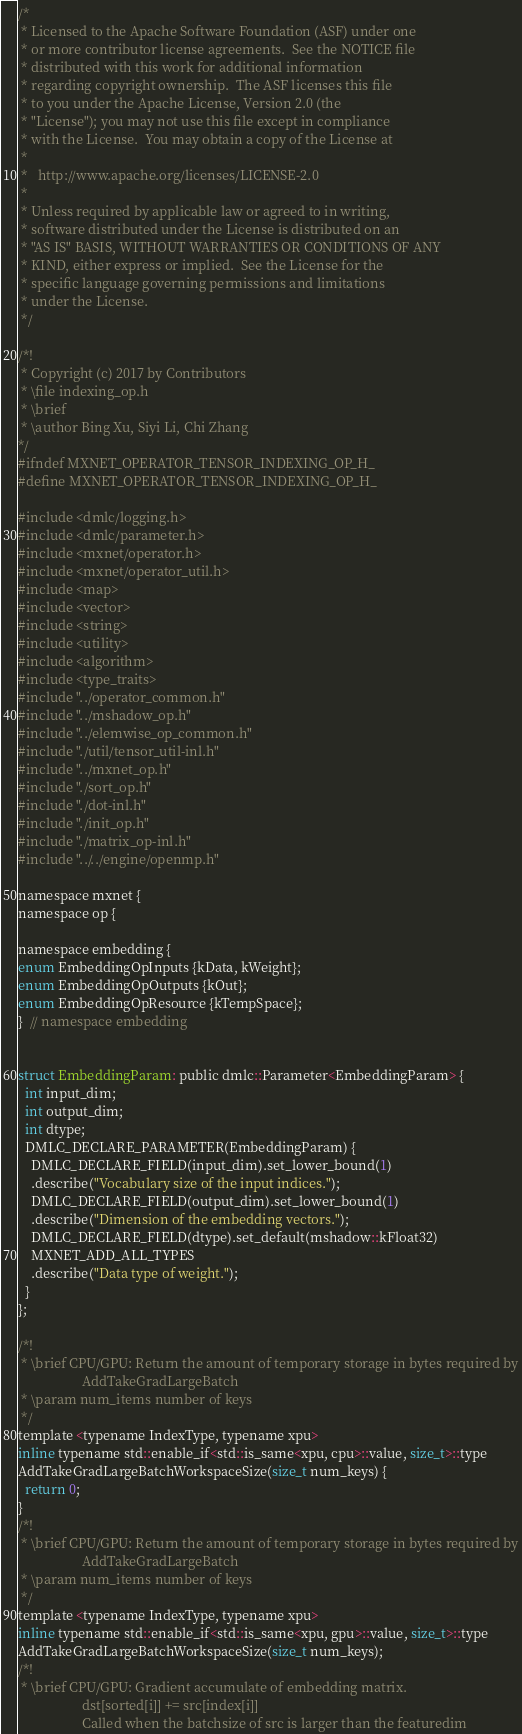Convert code to text. <code><loc_0><loc_0><loc_500><loc_500><_C_>/*
 * Licensed to the Apache Software Foundation (ASF) under one
 * or more contributor license agreements.  See the NOTICE file
 * distributed with this work for additional information
 * regarding copyright ownership.  The ASF licenses this file
 * to you under the Apache License, Version 2.0 (the
 * "License"); you may not use this file except in compliance
 * with the License.  You may obtain a copy of the License at
 *
 *   http://www.apache.org/licenses/LICENSE-2.0
 *
 * Unless required by applicable law or agreed to in writing,
 * software distributed under the License is distributed on an
 * "AS IS" BASIS, WITHOUT WARRANTIES OR CONDITIONS OF ANY
 * KIND, either express or implied.  See the License for the
 * specific language governing permissions and limitations
 * under the License.
 */

/*!
 * Copyright (c) 2017 by Contributors
 * \file indexing_op.h
 * \brief
 * \author Bing Xu, Siyi Li, Chi Zhang
*/
#ifndef MXNET_OPERATOR_TENSOR_INDEXING_OP_H_
#define MXNET_OPERATOR_TENSOR_INDEXING_OP_H_

#include <dmlc/logging.h>
#include <dmlc/parameter.h>
#include <mxnet/operator.h>
#include <mxnet/operator_util.h>
#include <map>
#include <vector>
#include <string>
#include <utility>
#include <algorithm>
#include <type_traits>
#include "../operator_common.h"
#include "../mshadow_op.h"
#include "../elemwise_op_common.h"
#include "./util/tensor_util-inl.h"
#include "../mxnet_op.h"
#include "./sort_op.h"
#include "./dot-inl.h"
#include "./init_op.h"
#include "./matrix_op-inl.h"
#include "../../engine/openmp.h"

namespace mxnet {
namespace op {

namespace embedding {
enum EmbeddingOpInputs {kData, kWeight};
enum EmbeddingOpOutputs {kOut};
enum EmbeddingOpResource {kTempSpace};
}  // namespace embedding


struct EmbeddingParam: public dmlc::Parameter<EmbeddingParam> {
  int input_dim;
  int output_dim;
  int dtype;
  DMLC_DECLARE_PARAMETER(EmbeddingParam) {
    DMLC_DECLARE_FIELD(input_dim).set_lower_bound(1)
    .describe("Vocabulary size of the input indices.");
    DMLC_DECLARE_FIELD(output_dim).set_lower_bound(1)
    .describe("Dimension of the embedding vectors.");
    DMLC_DECLARE_FIELD(dtype).set_default(mshadow::kFloat32)
    MXNET_ADD_ALL_TYPES
    .describe("Data type of weight.");
  }
};

/*!
 * \brief CPU/GPU: Return the amount of temporary storage in bytes required by
                   AddTakeGradLargeBatch
 * \param num_items number of keys
 */
template <typename IndexType, typename xpu>
inline typename std::enable_if<std::is_same<xpu, cpu>::value, size_t>::type
AddTakeGradLargeBatchWorkspaceSize(size_t num_keys) {
  return 0;
}
/*!
 * \brief CPU/GPU: Return the amount of temporary storage in bytes required by
                   AddTakeGradLargeBatch
 * \param num_items number of keys
 */
template <typename IndexType, typename xpu>
inline typename std::enable_if<std::is_same<xpu, gpu>::value, size_t>::type
AddTakeGradLargeBatchWorkspaceSize(size_t num_keys);
/*!
 * \brief CPU/GPU: Gradient accumulate of embedding matrix.
                   dst[sorted[i]] += src[index[i]]
                   Called when the batchsize of src is larger than the featuredim</code> 